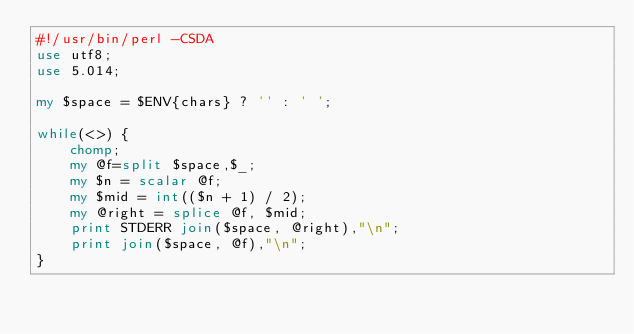Convert code to text. <code><loc_0><loc_0><loc_500><loc_500><_Perl_>#!/usr/bin/perl -CSDA
use utf8;
use 5.014;

my $space = $ENV{chars} ? '' : ' ';

while(<>) {
    chomp;
    my @f=split $space,$_;
    my $n = scalar @f;
    my $mid = int(($n + 1) / 2);
    my @right = splice @f, $mid;
    print STDERR join($space, @right),"\n";
    print join($space, @f),"\n";
}
</code> 